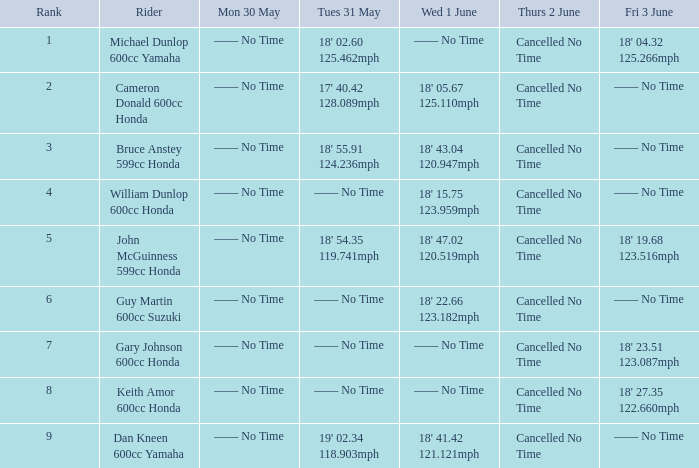On friday, june 3, what is the expected time for a rider who had a time of 18' 22.66 and a speed of 123.182 mph on wednesday, june 1? —— No Time. I'm looking to parse the entire table for insights. Could you assist me with that? {'header': ['Rank', 'Rider', 'Mon 30 May', 'Tues 31 May', 'Wed 1 June', 'Thurs 2 June', 'Fri 3 June'], 'rows': [['1', 'Michael Dunlop 600cc Yamaha', '—— No Time', "18' 02.60 125.462mph", '—— No Time', 'Cancelled No Time', "18' 04.32 125.266mph"], ['2', 'Cameron Donald 600cc Honda', '—— No Time', "17' 40.42 128.089mph", "18' 05.67 125.110mph", 'Cancelled No Time', '—— No Time'], ['3', 'Bruce Anstey 599cc Honda', '—— No Time', "18' 55.91 124.236mph", "18' 43.04 120.947mph", 'Cancelled No Time', '—— No Time'], ['4', 'William Dunlop 600cc Honda', '—— No Time', '—— No Time', "18' 15.75 123.959mph", 'Cancelled No Time', '—— No Time'], ['5', 'John McGuinness 599cc Honda', '—— No Time', "18' 54.35 119.741mph", "18' 47.02 120.519mph", 'Cancelled No Time', "18' 19.68 123.516mph"], ['6', 'Guy Martin 600cc Suzuki', '—— No Time', '—— No Time', "18' 22.66 123.182mph", 'Cancelled No Time', '—— No Time'], ['7', 'Gary Johnson 600cc Honda', '—— No Time', '—— No Time', '—— No Time', 'Cancelled No Time', "18' 23.51 123.087mph"], ['8', 'Keith Amor 600cc Honda', '—— No Time', '—— No Time', '—— No Time', 'Cancelled No Time', "18' 27.35 122.660mph"], ['9', 'Dan Kneen 600cc Yamaha', '—— No Time', "19' 02.34 118.903mph", "18' 41.42 121.121mph", 'Cancelled No Time', '—— No Time']]} 